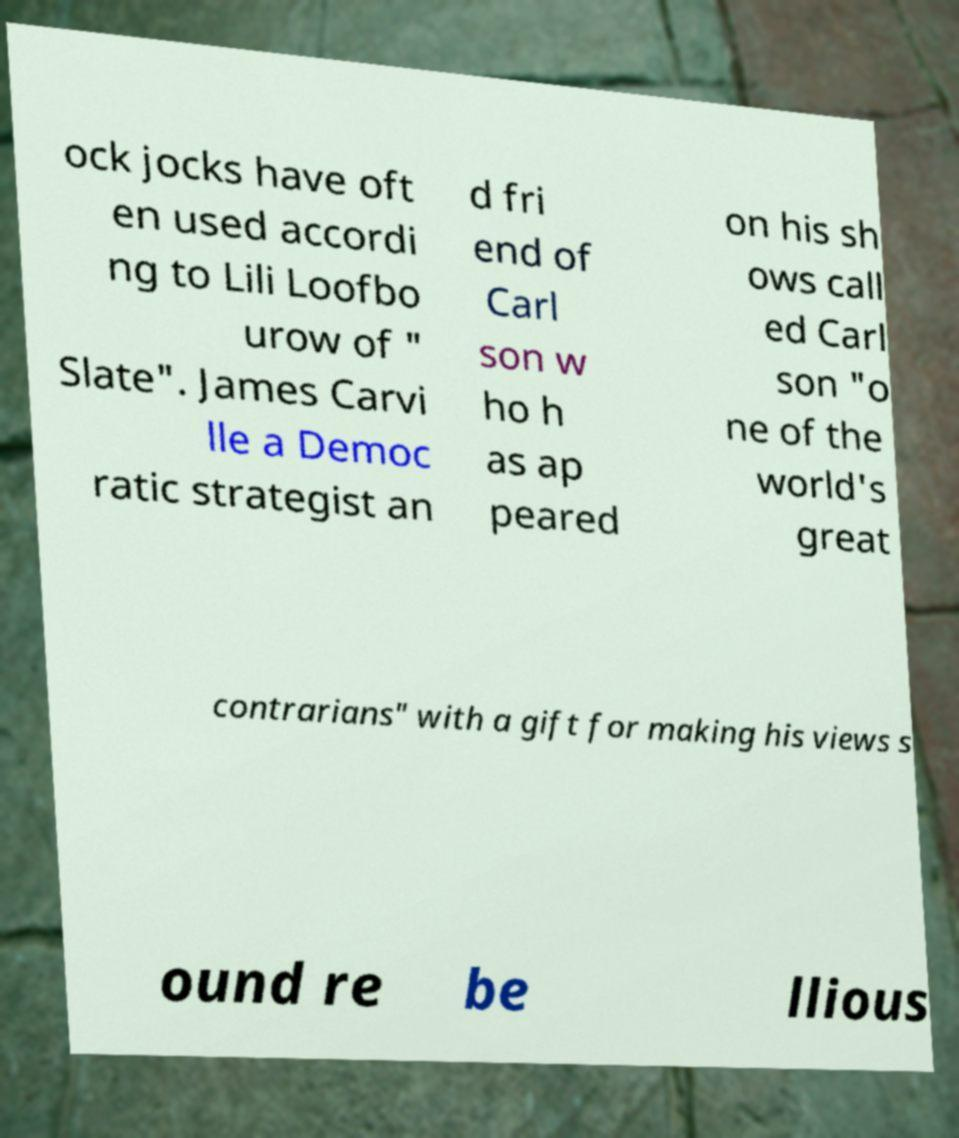Please identify and transcribe the text found in this image. ock jocks have oft en used accordi ng to Lili Loofbo urow of " Slate". James Carvi lle a Democ ratic strategist an d fri end of Carl son w ho h as ap peared on his sh ows call ed Carl son "o ne of the world's great contrarians" with a gift for making his views s ound re be llious 